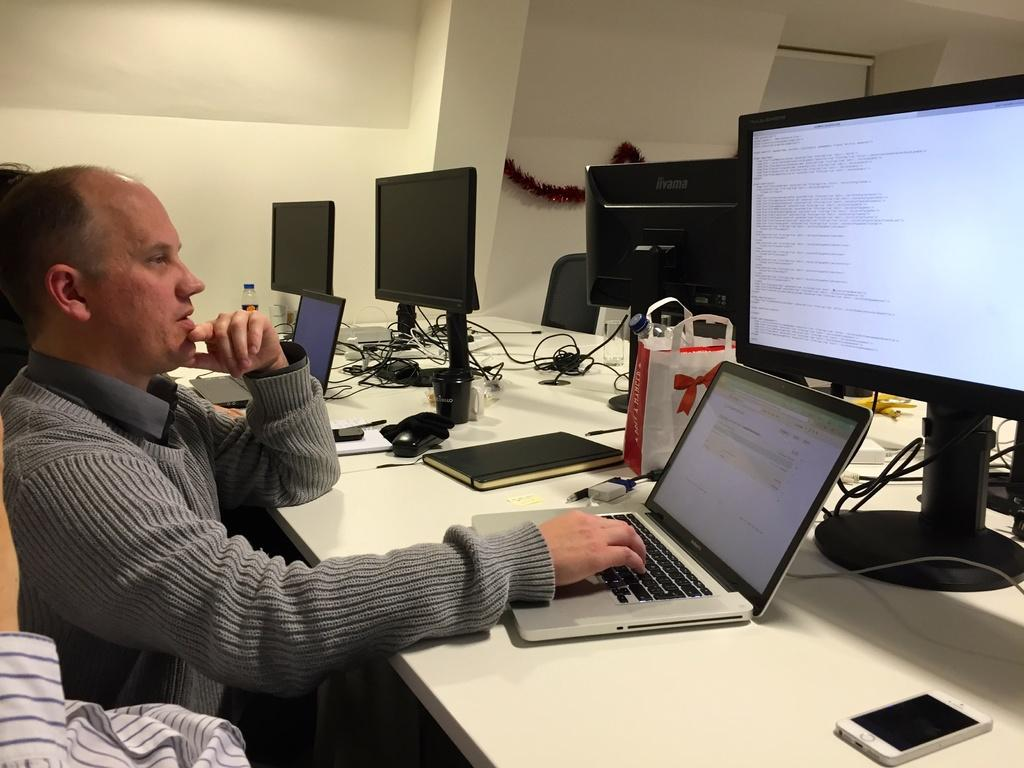How many monitors are visible in the image? There are three monitors in the image. What other electronic devices can be seen in the image? There are two laptops in the image. Where are the laptops and monitors located? The laptops and monitors are on a table in the image. What is the man in the image doing? The man is using a laptop in the image. How many rings does the man have on his fingers in the image? There is no information about rings or the man's fingers in the image. What level of respect does the man show towards the jellyfish in the image? There are no jellyfish present in the image, so it is not possible to determine the man's level of respect towards them. 